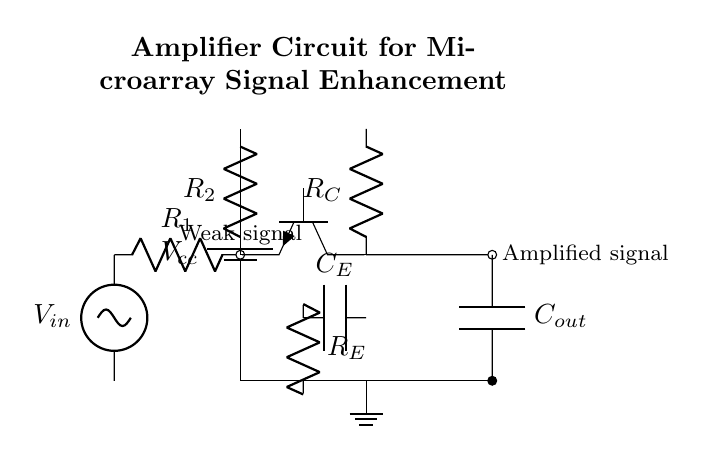What is the power supply voltage in this circuit? The power supply voltage is labeled as V cc, which is typically connected to power sources in amplifier circuits. The exact value is not specified here, but it indicates that there is a supply voltage needed for operation.
Answer: V cc What type of transistor is used in this circuit? The diagram clearly indicates the use of an NPN transistor, denoted by the symbol T npn in the circuit. This helps us understand that the circuit is designed to amplify weak signals, which is a common use for NPN transistors.
Answer: NPN What is the role of resistor R 2 in this amplifier circuit? Resistor R 2 is connected in series with the collector of the transistor and acts as a load resistor. It contributes to setting the voltage and current levels in the circuit, which inherently affects the overall amplification of the signal.
Answer: Load resistor What happens to the input signal at the output? The output signal labeled as "Amplified signal" shows that the weak input signal (V in) is processed through the amplifier and results in an amplified version. This indicates the purpose of the amplifier circuit is to enhance weak signals effectively.
Answer: It is amplified Why is a capacitor C out connected at the output? The capacitor C out serves to block any DC component from the amplified output signal, allowing only the AC signals to pass through. This is crucial for signal integrity, particularly in applications like microarray experiments where only varying signals are of interest.
Answer: To block DC component What is the significance of the emitter resistor R E? The emitter resistor R E stabilizes the operating point of the transistor by providing negative feedback. This feedback helps to control the gain of the circuit and improves the linearity, which is essential in precision applications such as microarray experiments.
Answer: Stabilizes gain 